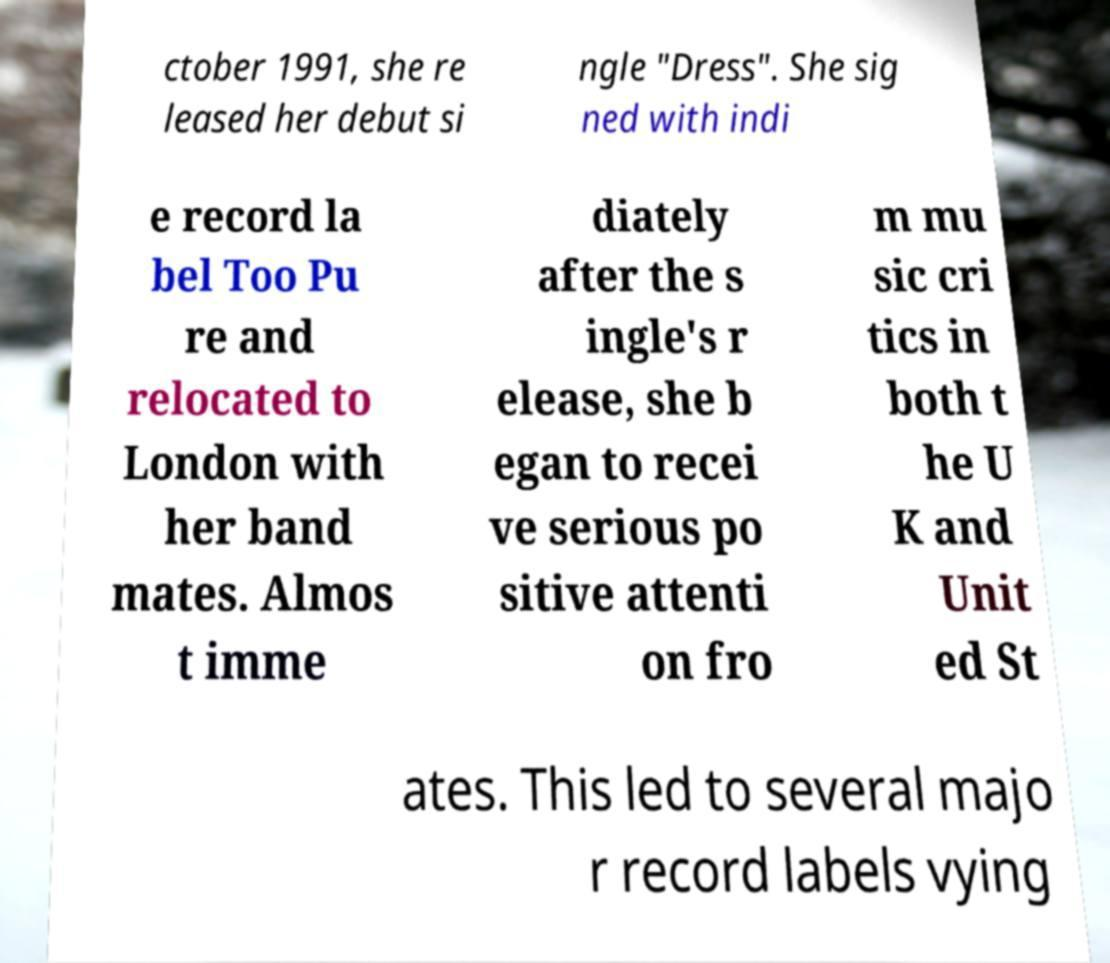Please read and relay the text visible in this image. What does it say? ctober 1991, she re leased her debut si ngle "Dress". She sig ned with indi e record la bel Too Pu re and relocated to London with her band mates. Almos t imme diately after the s ingle's r elease, she b egan to recei ve serious po sitive attenti on fro m mu sic cri tics in both t he U K and Unit ed St ates. This led to several majo r record labels vying 